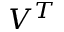Convert formula to latex. <formula><loc_0><loc_0><loc_500><loc_500>V ^ { T }</formula> 